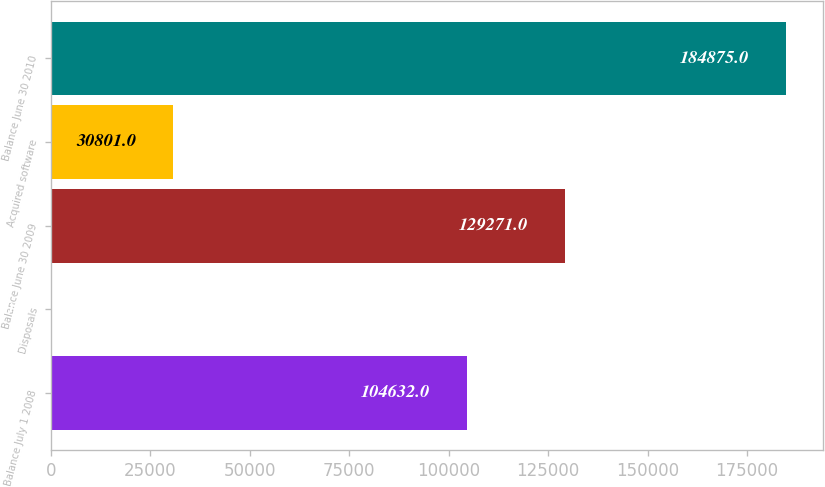Convert chart to OTSL. <chart><loc_0><loc_0><loc_500><loc_500><bar_chart><fcel>Balance July 1 2008<fcel>Disposals<fcel>Balance June 30 2009<fcel>Acquired software<fcel>Balance June 30 2010<nl><fcel>104632<fcel>45<fcel>129271<fcel>30801<fcel>184875<nl></chart> 